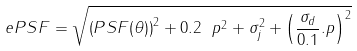<formula> <loc_0><loc_0><loc_500><loc_500>e P S F = \sqrt { \left ( P S F ( \theta ) \right ) ^ { 2 } + 0 . 2 \ p ^ { 2 } + \sigma _ { j } ^ { 2 } + \left ( \frac { \sigma _ { d } } { 0 . 1 } . p \right ) ^ { 2 } }</formula> 